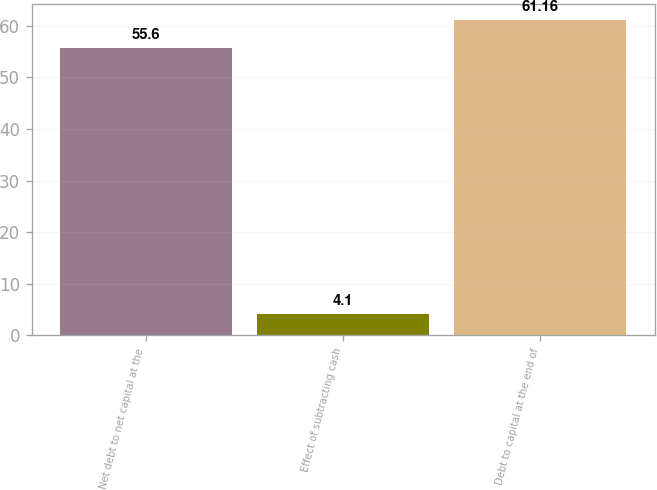Convert chart to OTSL. <chart><loc_0><loc_0><loc_500><loc_500><bar_chart><fcel>Net debt to net capital at the<fcel>Effect of subtracting cash<fcel>Debt to capital at the end of<nl><fcel>55.6<fcel>4.1<fcel>61.16<nl></chart> 